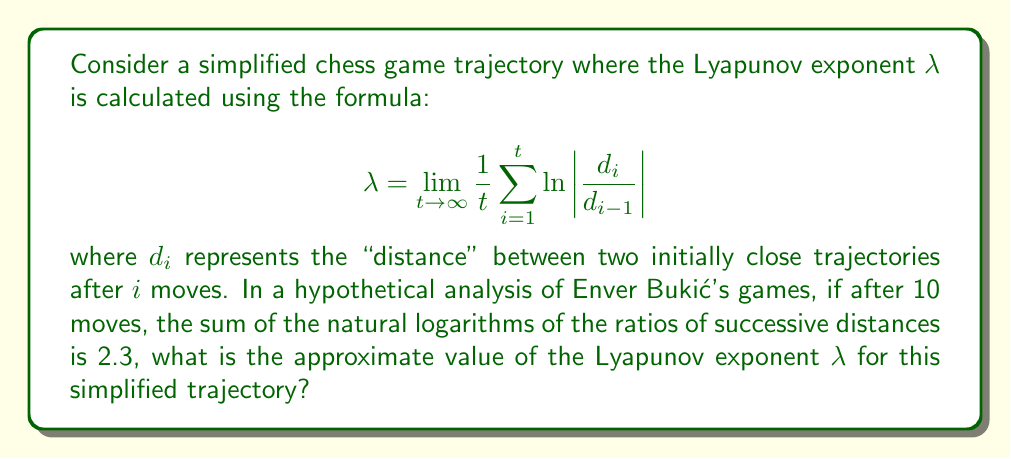Can you solve this math problem? To solve this problem, let's break it down step-by-step:

1) The Lyapunov exponent formula is given as:

   $$ λ = \lim_{t→∞} \frac{1}{t} \sum_{i=1}^{t} \ln \left|\frac{d_i}{d_{i-1}}\right| $$

2) In our case, we're given that after 10 moves (t = 10), the sum of the natural logarithms is 2.3:

   $$ \sum_{i=1}^{10} \ln \left|\frac{d_i}{d_{i-1}}\right| = 2.3 $$

3) To approximate the Lyapunov exponent, we can use this finite time approximation:

   $$ λ ≈ \frac{1}{t} \sum_{i=1}^{t} \ln \left|\frac{d_i}{d_{i-1}}\right| $$

4) Substituting our known values:

   $$ λ ≈ \frac{1}{10} \cdot 2.3 $$

5) Calculating:

   $$ λ ≈ 0.23 $$

Therefore, the approximate value of the Lyapunov exponent λ for this simplified trajectory of Enver Bukić's game is 0.23.
Answer: $0.23$ 